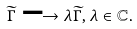<formula> <loc_0><loc_0><loc_500><loc_500>\widetilde { \Gamma } \longrightarrow \lambda \widetilde { \Gamma } , \lambda \in \mathbb { C } .</formula> 